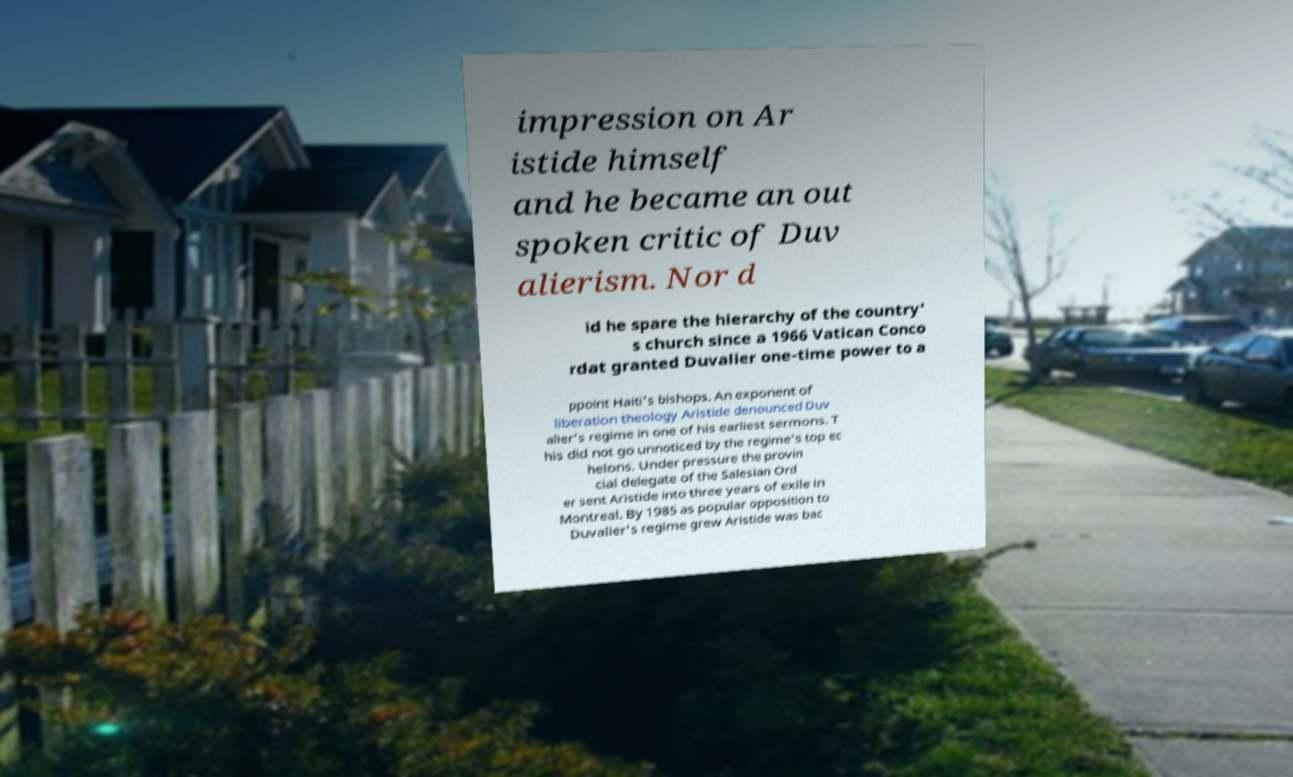Can you read and provide the text displayed in the image?This photo seems to have some interesting text. Can you extract and type it out for me? impression on Ar istide himself and he became an out spoken critic of Duv alierism. Nor d id he spare the hierarchy of the country' s church since a 1966 Vatican Conco rdat granted Duvalier one-time power to a ppoint Haiti's bishops. An exponent of liberation theology Aristide denounced Duv alier's regime in one of his earliest sermons. T his did not go unnoticed by the regime's top ec helons. Under pressure the provin cial delegate of the Salesian Ord er sent Aristide into three years of exile in Montreal. By 1985 as popular opposition to Duvalier's regime grew Aristide was bac 